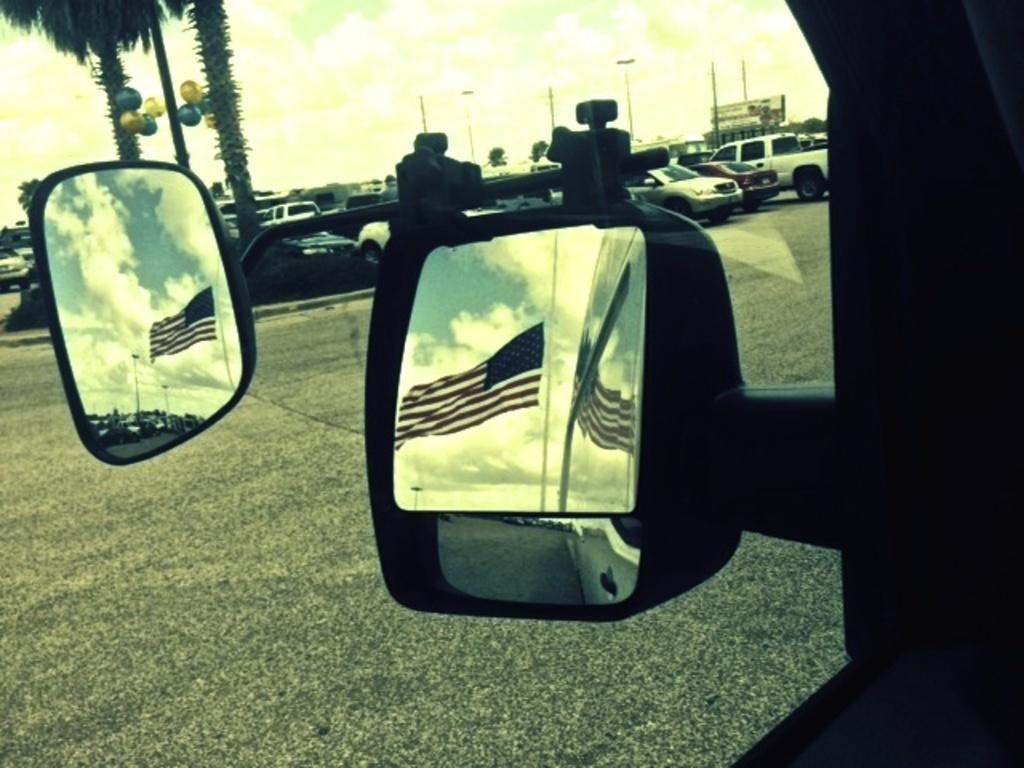How would you summarize this image in a sentence or two? In this picture I can see the mirrors in the middle, there are reflected images of a flag on them, in the background I can see few cars and trees. At the top, there is the sky. 